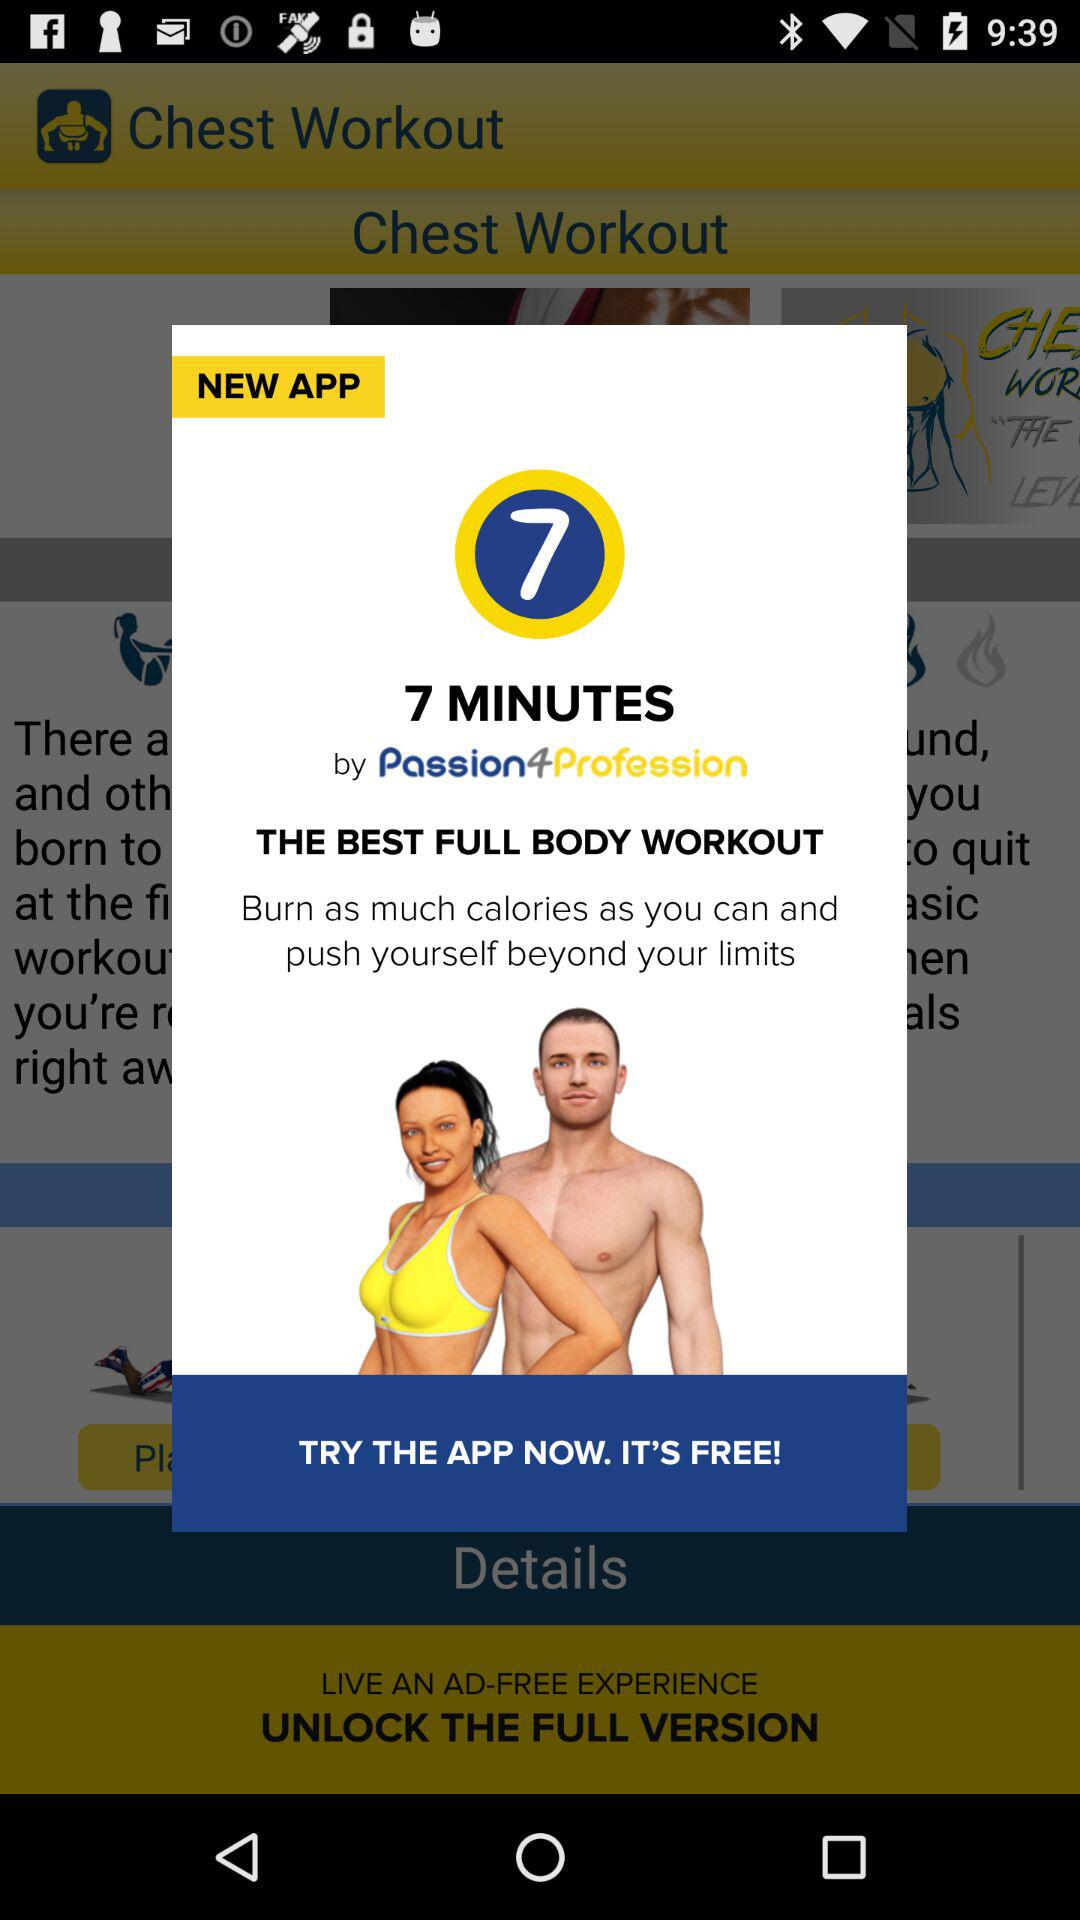What is the application name? The application names are "Chest Workout" and "7 MINUTES". 